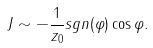<formula> <loc_0><loc_0><loc_500><loc_500>J \sim - \frac { 1 } { z _ { 0 } } s g n ( \varphi ) \cos \varphi .</formula> 